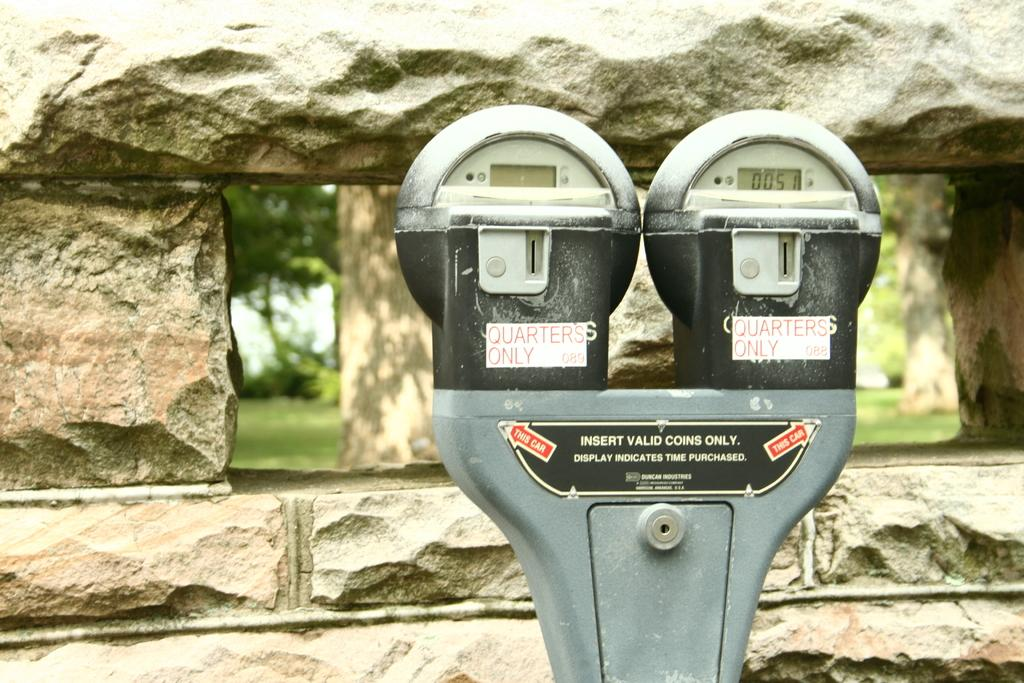<image>
Present a compact description of the photo's key features. a dual parking meter that reads Quarters Only 